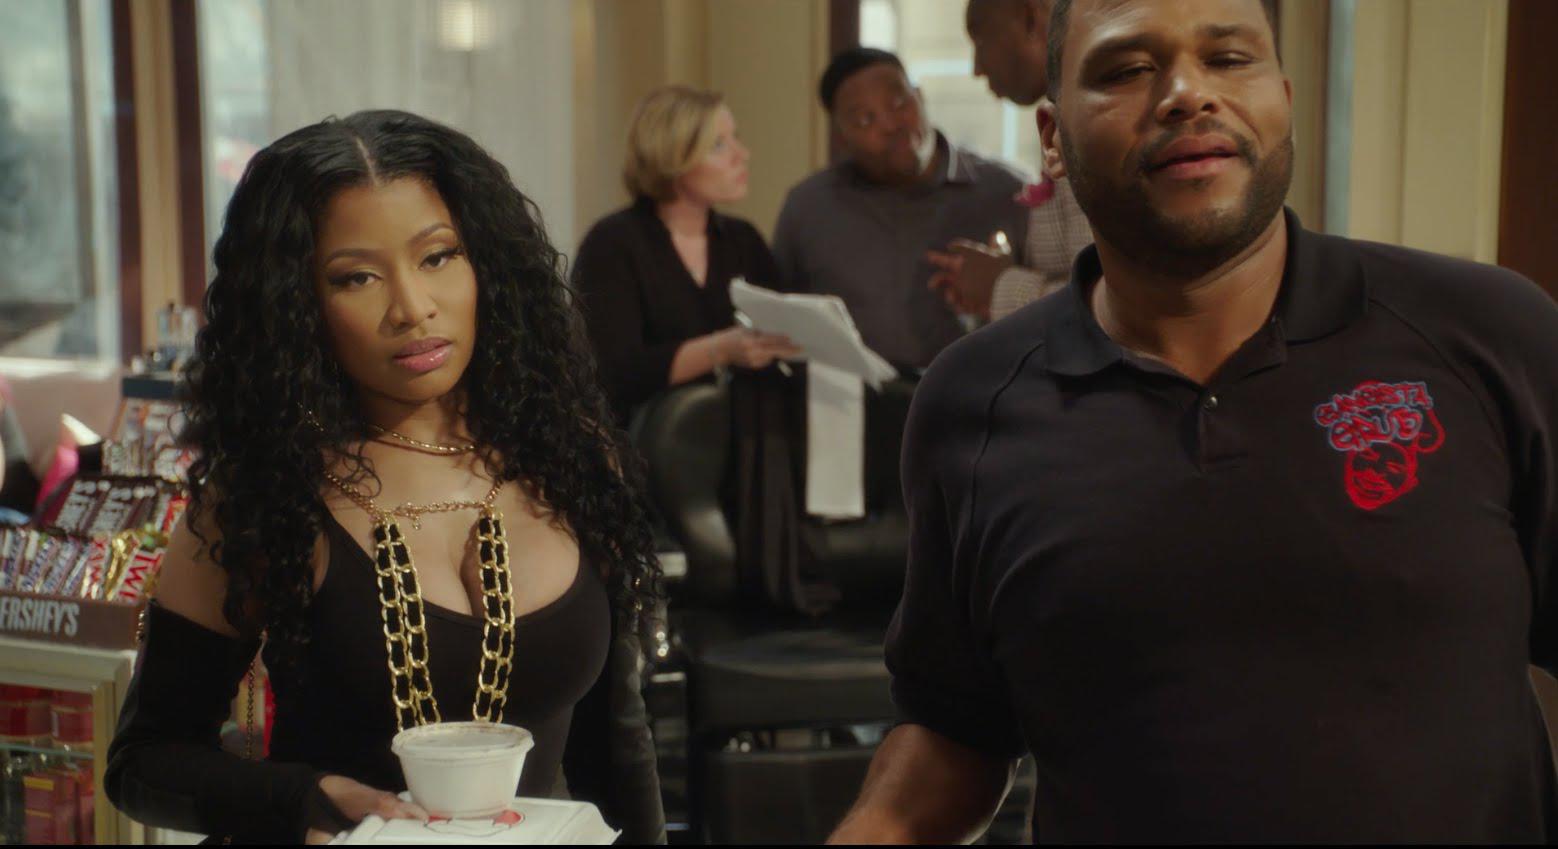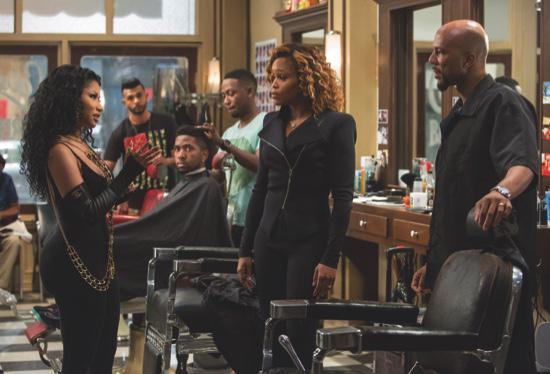The first image is the image on the left, the second image is the image on the right. Evaluate the accuracy of this statement regarding the images: "There is at least one image of a man sitting in a barber chair.". Is it true? Answer yes or no. Yes. The first image is the image on the left, the second image is the image on the right. Examine the images to the left and right. Is the description "The person in the right image furthest to the right has a bald scalp." accurate? Answer yes or no. Yes. 